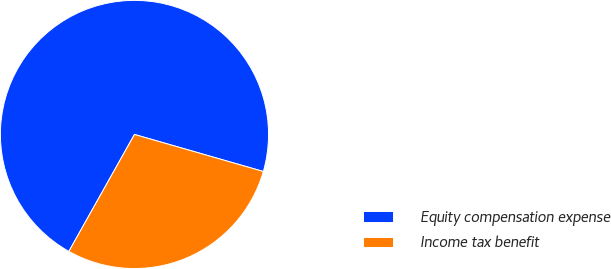Convert chart to OTSL. <chart><loc_0><loc_0><loc_500><loc_500><pie_chart><fcel>Equity compensation expense<fcel>Income tax benefit<nl><fcel>71.32%<fcel>28.68%<nl></chart> 